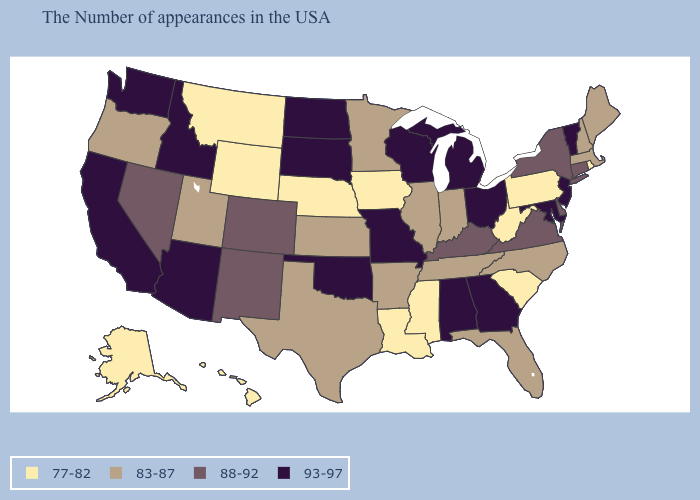Does Illinois have a higher value than New York?
Concise answer only. No. What is the value of New Hampshire?
Answer briefly. 83-87. Which states have the highest value in the USA?
Answer briefly. Vermont, New Jersey, Maryland, Ohio, Georgia, Michigan, Alabama, Wisconsin, Missouri, Oklahoma, South Dakota, North Dakota, Arizona, Idaho, California, Washington. Does South Dakota have the highest value in the USA?
Concise answer only. Yes. Among the states that border Indiana , does Kentucky have the highest value?
Short answer required. No. Name the states that have a value in the range 88-92?
Answer briefly. Connecticut, New York, Delaware, Virginia, Kentucky, Colorado, New Mexico, Nevada. Does Michigan have the highest value in the USA?
Quick response, please. Yes. Among the states that border Arizona , which have the highest value?
Be succinct. California. What is the value of North Carolina?
Concise answer only. 83-87. Does Indiana have the highest value in the MidWest?
Write a very short answer. No. Which states have the lowest value in the West?
Be succinct. Wyoming, Montana, Alaska, Hawaii. What is the value of California?
Give a very brief answer. 93-97. Does Pennsylvania have the lowest value in the USA?
Concise answer only. Yes. Among the states that border Wyoming , does South Dakota have the highest value?
Give a very brief answer. Yes. 